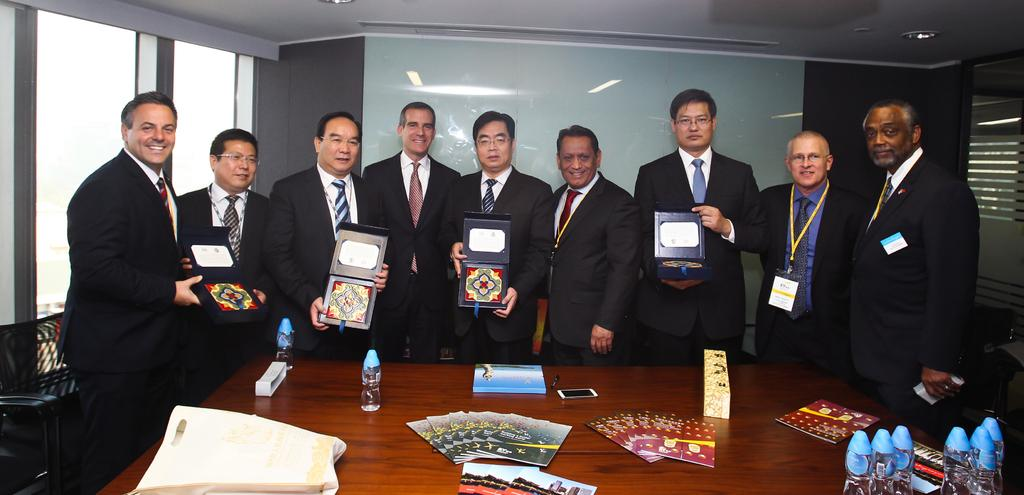What are the people in the room doing? The people in the room are standing and holding boxes. What is in front of the people? There is a table in front of the people. What can be seen on the table? There are bottles, a cellphone, a book, and other objects on the table. What type of bell can be heard ringing in the image? There is no bell present in the image, and therefore no sound can be heard. Can you see a horse in the image? There is no horse present in the image. 